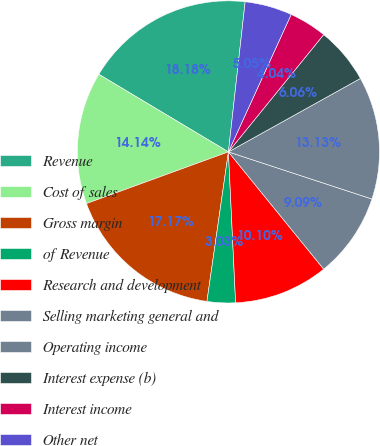<chart> <loc_0><loc_0><loc_500><loc_500><pie_chart><fcel>Revenue<fcel>Cost of sales<fcel>Gross margin<fcel>of Revenue<fcel>Research and development<fcel>Selling marketing general and<fcel>Operating income<fcel>Interest expense (b)<fcel>Interest income<fcel>Other net<nl><fcel>18.18%<fcel>14.14%<fcel>17.17%<fcel>3.03%<fcel>10.1%<fcel>9.09%<fcel>13.13%<fcel>6.06%<fcel>4.04%<fcel>5.05%<nl></chart> 